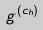Convert formula to latex. <formula><loc_0><loc_0><loc_500><loc_500>g ^ { ( c _ { h } ) }</formula> 